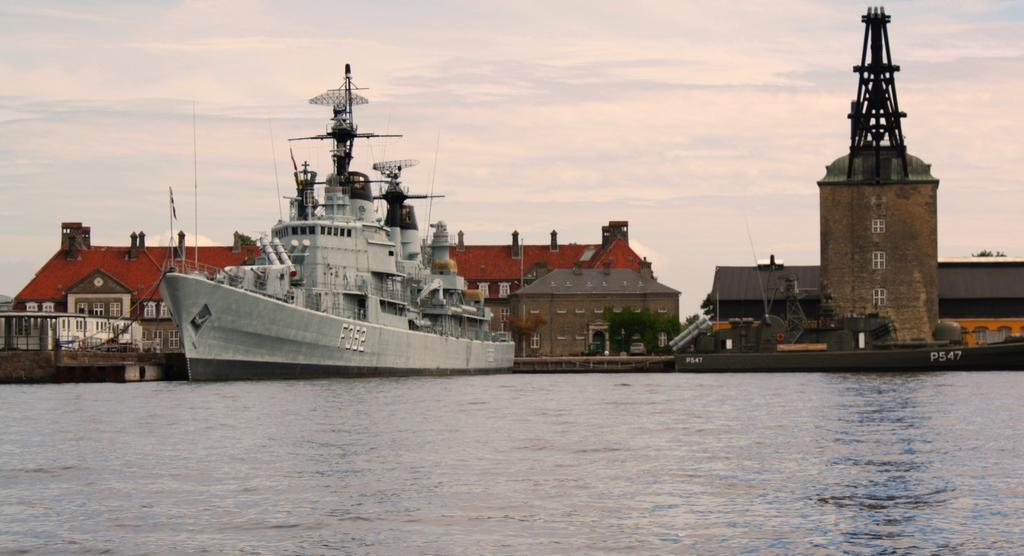What is the main subject of the image? The main subject of the image is a ship on the water. What other structures or objects can be seen in the image? There are houses, plants, windows, poles, flags, and a tower visible in the image. What is the condition of the sky in the image? The sky is visible in the image, and there are clouds present. What type of grain is being harvested in the image? There is no grain present in the image; it features a ship on the water and various structures and objects on land. Can you describe the argument taking place between the houses in the image? There is no argument depicted in the image; it shows a ship on the water and various structures and objects on land. 